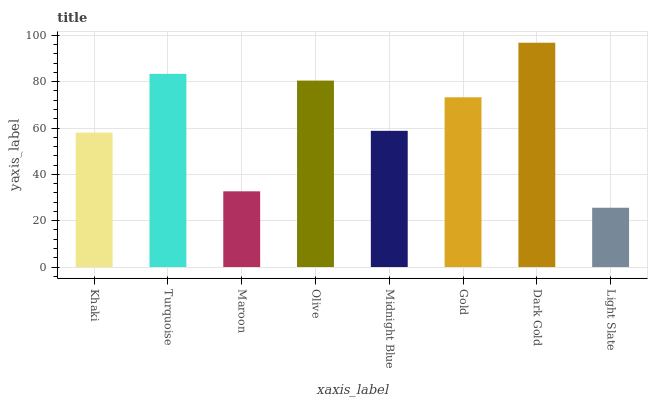Is Light Slate the minimum?
Answer yes or no. Yes. Is Dark Gold the maximum?
Answer yes or no. Yes. Is Turquoise the minimum?
Answer yes or no. No. Is Turquoise the maximum?
Answer yes or no. No. Is Turquoise greater than Khaki?
Answer yes or no. Yes. Is Khaki less than Turquoise?
Answer yes or no. Yes. Is Khaki greater than Turquoise?
Answer yes or no. No. Is Turquoise less than Khaki?
Answer yes or no. No. Is Gold the high median?
Answer yes or no. Yes. Is Midnight Blue the low median?
Answer yes or no. Yes. Is Midnight Blue the high median?
Answer yes or no. No. Is Khaki the low median?
Answer yes or no. No. 